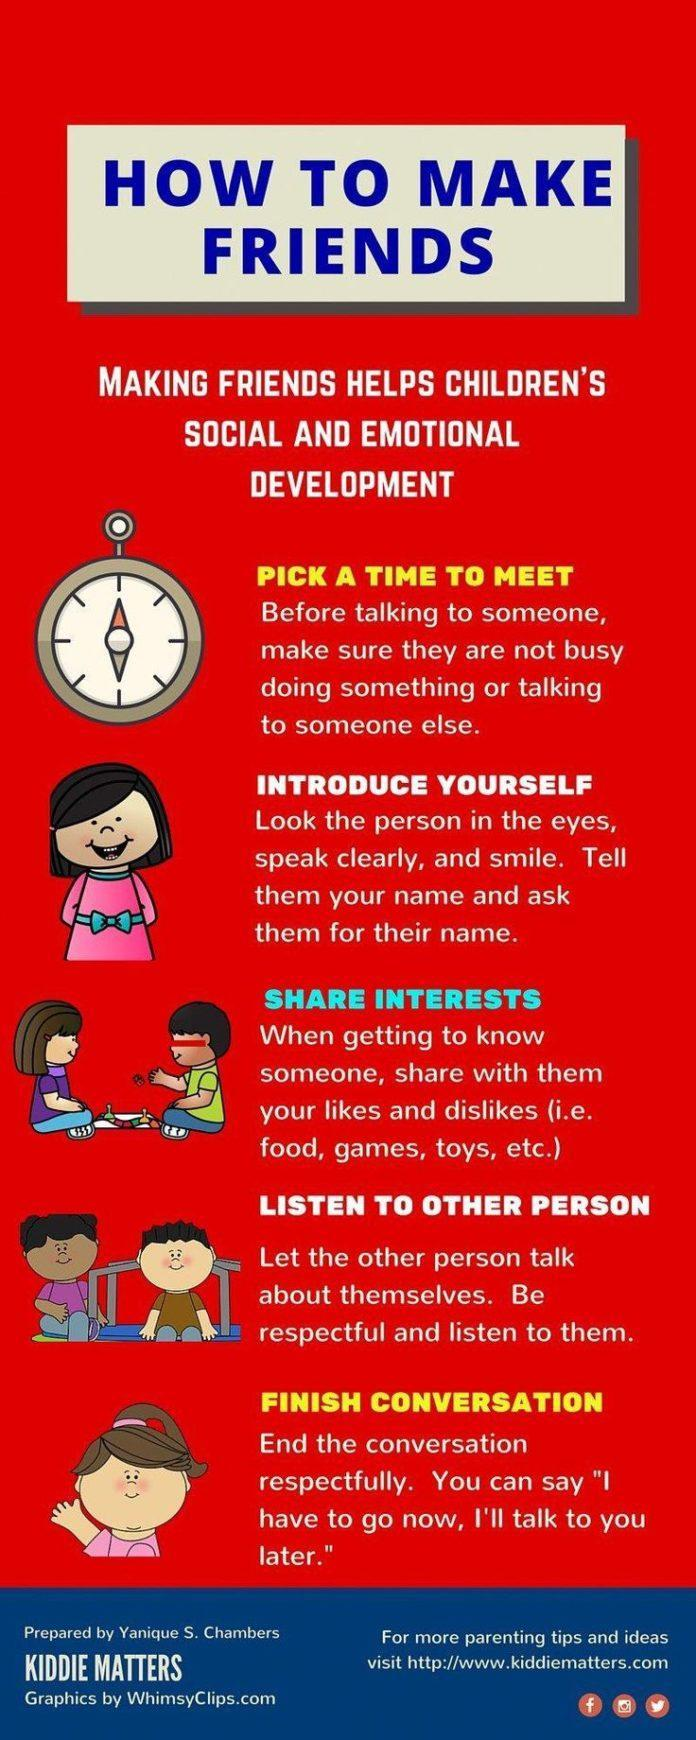How many children are in this infographic?
Answer the question with a short phrase. 6 How many girls are in this infographic? 4 How many points are under the heading of how to make friends? 5 How many boys are in this infographic? 2 What is the second point under the heading of how to make friends? Introduce Yourself 